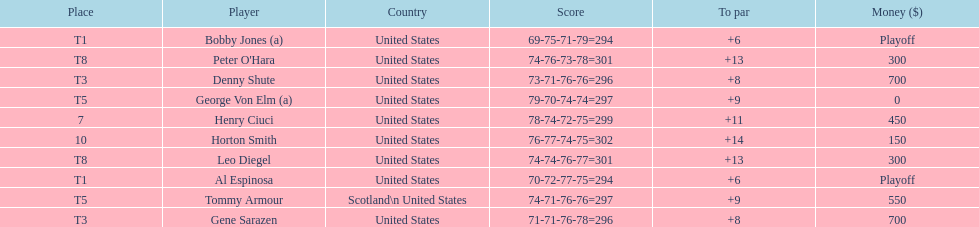Which two players tied for first place? Bobby Jones (a), Al Espinosa. 